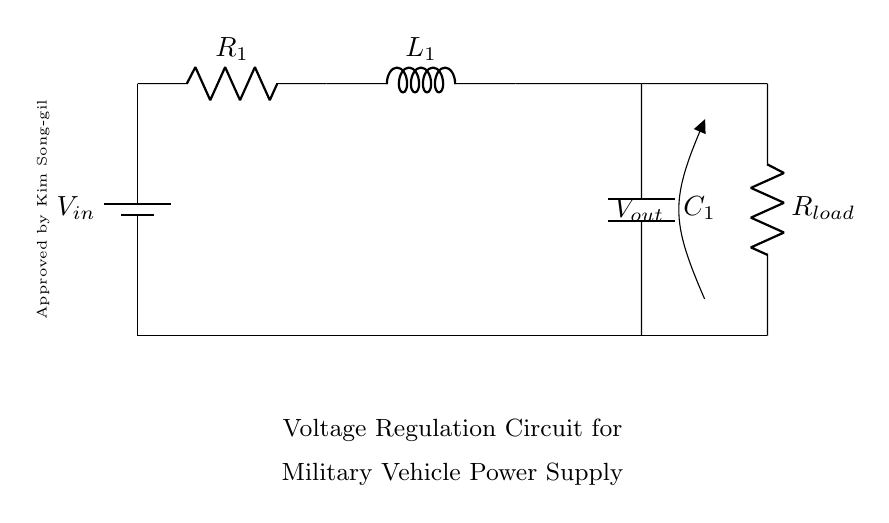What is the input voltage of this circuit? The input voltage, denoted as V_in, is the voltage supplied by the battery at the top of the circuit.
Answer: V_in What components are present in this circuit? The circuit includes a battery, a resistor (R1), an inductor (L1), and a capacitor (C1), along with a load resistor (R_load).
Answer: Battery, R1, L1, C1, R_load What is the purpose of the capacitor in this circuit? The capacitor is used for filtering and stabilizing the voltage output by smoothing out fluctuations caused by the varying load conditions.
Answer: Smoothing voltage What is the significance of V_out in this circuit? V_out represents the output voltage across the load resistor (R_load), which supplies power to the load, indicating the stability of the output voltage for the vehicle's electronics.
Answer: Output voltage How do the components affect the stability of the power supply? The resistor limits current, the inductor stores energy and resists changes in current, and the capacitor smooths out voltage fluctuations, together helping maintain a stable power supply.
Answer: Stabilizes power supply What is the load resistor's role in the circuit? The load resistor (R_load) is connected in parallel with the output and represents the device or system consuming power, demonstrating the circuit's ability to provide voltage under load.
Answer: Power consumption 